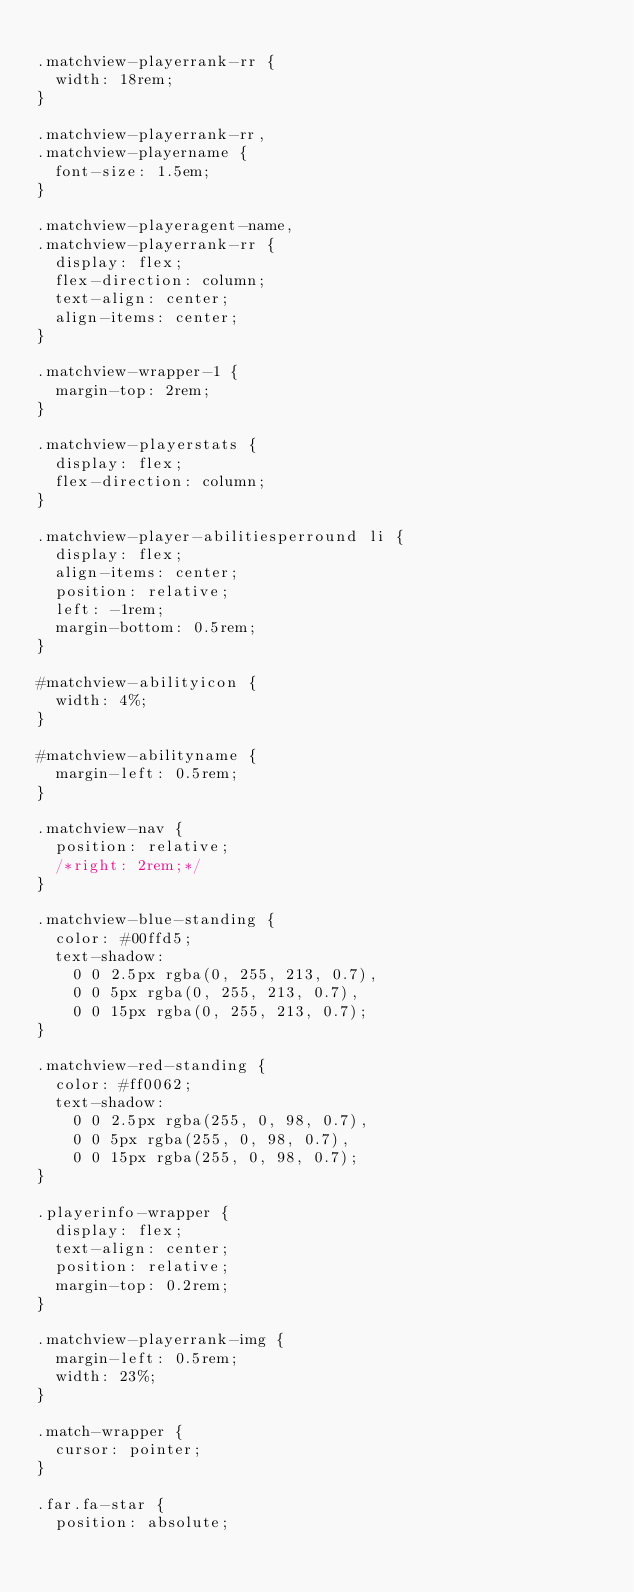Convert code to text. <code><loc_0><loc_0><loc_500><loc_500><_CSS_>
.matchview-playerrank-rr {
  width: 18rem;
}

.matchview-playerrank-rr,
.matchview-playername {
  font-size: 1.5em;
}

.matchview-playeragent-name,
.matchview-playerrank-rr {
  display: flex;
  flex-direction: column;
  text-align: center;
  align-items: center;
}

.matchview-wrapper-1 {
  margin-top: 2rem;
}

.matchview-playerstats {
  display: flex;
  flex-direction: column;
}

.matchview-player-abilitiesperround li {
  display: flex;
  align-items: center;
  position: relative;
  left: -1rem;
  margin-bottom: 0.5rem;
}

#matchview-abilityicon {
  width: 4%;
}

#matchview-abilityname {
  margin-left: 0.5rem;
}

.matchview-nav {
  position: relative;
  /*right: 2rem;*/
}

.matchview-blue-standing {
  color: #00ffd5;
  text-shadow:
    0 0 2.5px rgba(0, 255, 213, 0.7),
    0 0 5px rgba(0, 255, 213, 0.7),
    0 0 15px rgba(0, 255, 213, 0.7);
}

.matchview-red-standing {
  color: #ff0062;
  text-shadow:
    0 0 2.5px rgba(255, 0, 98, 0.7),
    0 0 5px rgba(255, 0, 98, 0.7),
    0 0 15px rgba(255, 0, 98, 0.7);
}

.playerinfo-wrapper {
  display: flex;
  text-align: center;
  position: relative;
  margin-top: 0.2rem;
}

.matchview-playerrank-img {
  margin-left: 0.5rem;
  width: 23%;
}

.match-wrapper {
  cursor: pointer;
}

.far.fa-star {
  position: absolute;</code> 